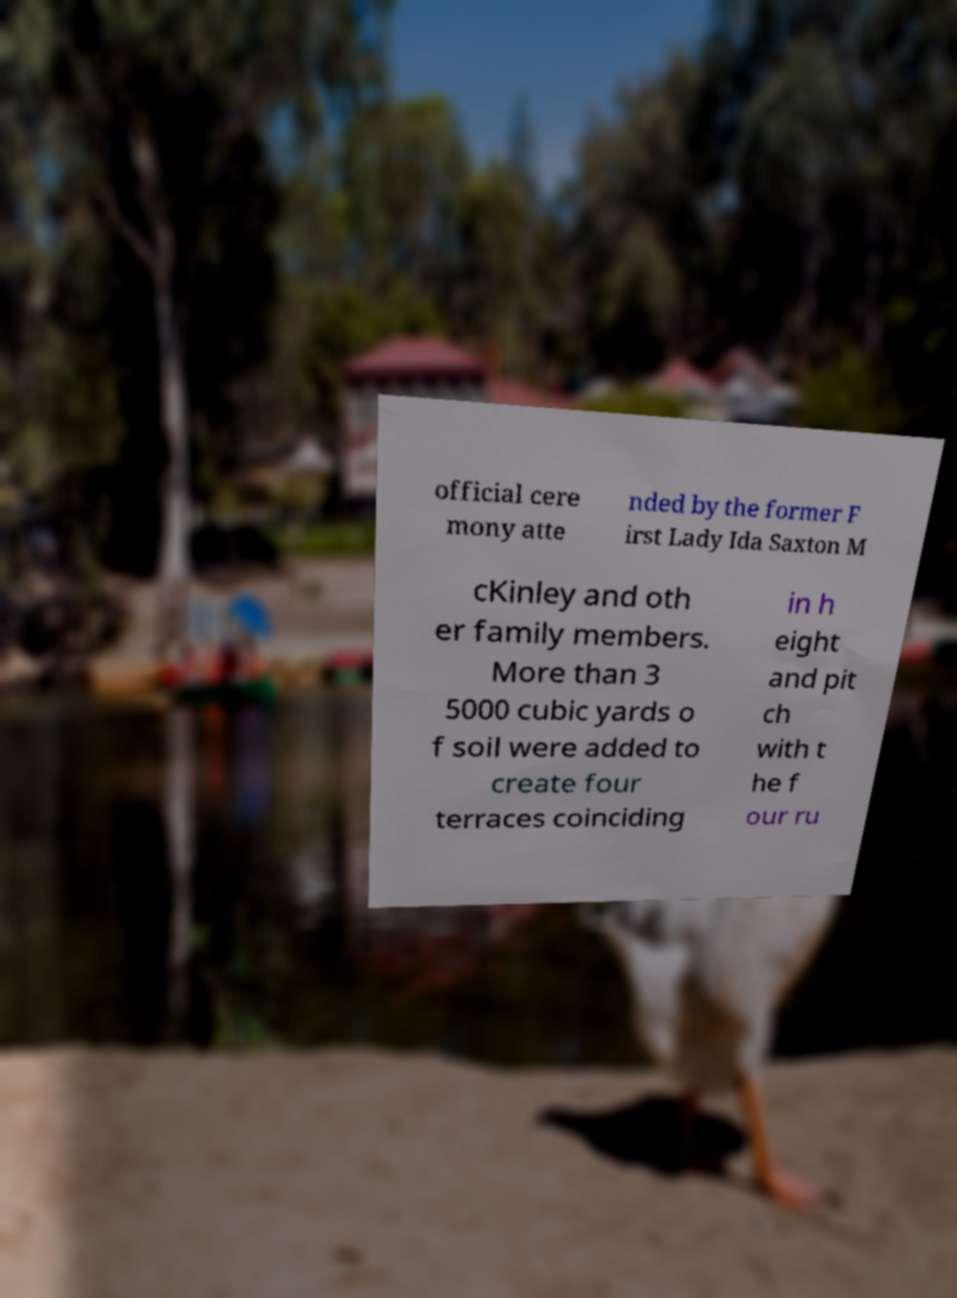What messages or text are displayed in this image? I need them in a readable, typed format. official cere mony atte nded by the former F irst Lady Ida Saxton M cKinley and oth er family members. More than 3 5000 cubic yards o f soil were added to create four terraces coinciding in h eight and pit ch with t he f our ru 